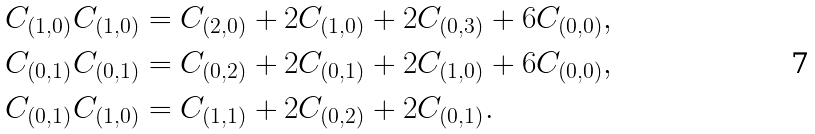<formula> <loc_0><loc_0><loc_500><loc_500>C _ { ( 1 , 0 ) } C _ { ( 1 , 0 ) } & = C _ { ( 2 , 0 ) } + 2 C _ { ( 1 , 0 ) } + 2 C _ { ( 0 , 3 ) } + 6 C _ { ( 0 , 0 ) } , \\ C _ { ( 0 , 1 ) } C _ { ( 0 , 1 ) } & = C _ { ( 0 , 2 ) } + 2 C _ { ( 0 , 1 ) } + 2 C _ { ( 1 , 0 ) } + 6 C _ { ( 0 , 0 ) } , \\ C _ { ( 0 , 1 ) } C _ { ( 1 , 0 ) } & = C _ { ( 1 , 1 ) } + 2 C _ { ( 0 , 2 ) } + 2 C _ { ( 0 , 1 ) } .</formula> 